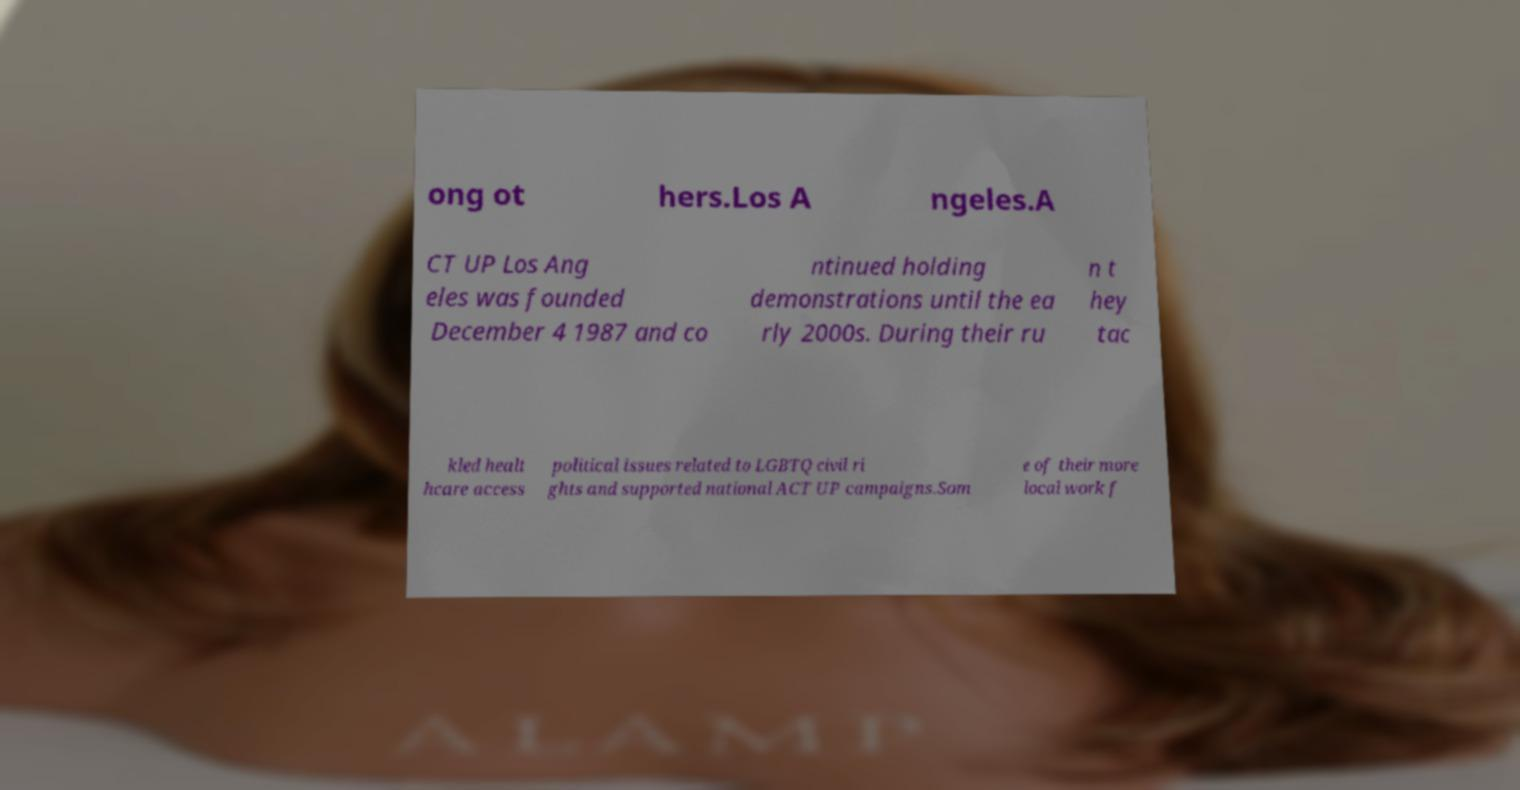I need the written content from this picture converted into text. Can you do that? ong ot hers.Los A ngeles.A CT UP Los Ang eles was founded December 4 1987 and co ntinued holding demonstrations until the ea rly 2000s. During their ru n t hey tac kled healt hcare access political issues related to LGBTQ civil ri ghts and supported national ACT UP campaigns.Som e of their more local work f 